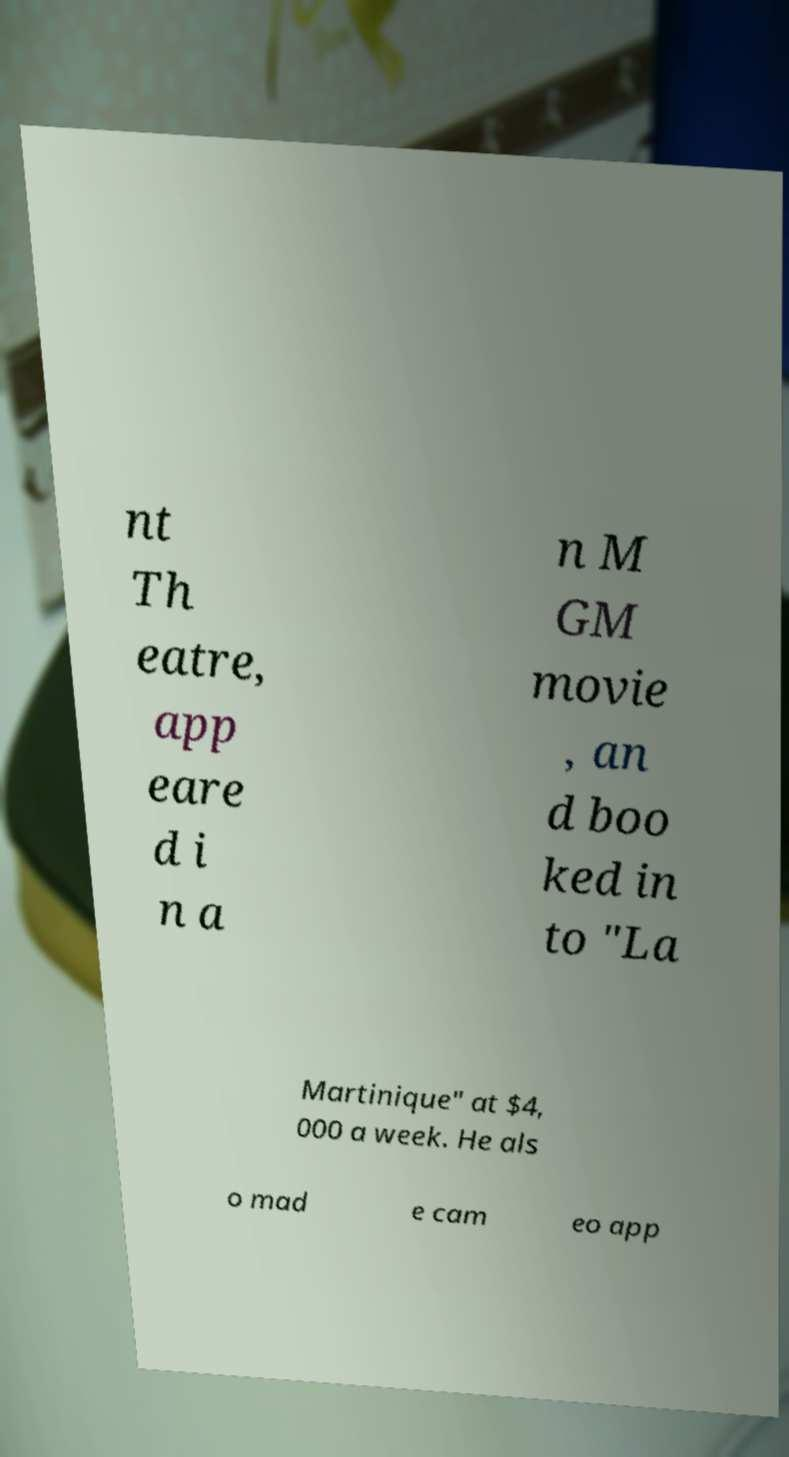Please identify and transcribe the text found in this image. nt Th eatre, app eare d i n a n M GM movie , an d boo ked in to "La Martinique" at $4, 000 a week. He als o mad e cam eo app 